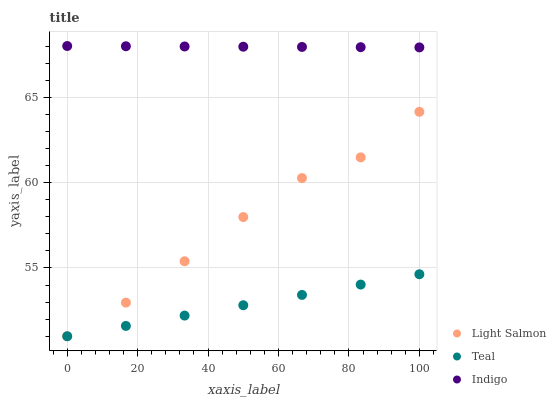Does Teal have the minimum area under the curve?
Answer yes or no. Yes. Does Indigo have the maximum area under the curve?
Answer yes or no. Yes. Does Indigo have the minimum area under the curve?
Answer yes or no. No. Does Teal have the maximum area under the curve?
Answer yes or no. No. Is Teal the smoothest?
Answer yes or no. Yes. Is Light Salmon the roughest?
Answer yes or no. Yes. Is Indigo the smoothest?
Answer yes or no. No. Is Indigo the roughest?
Answer yes or no. No. Does Light Salmon have the lowest value?
Answer yes or no. Yes. Does Indigo have the lowest value?
Answer yes or no. No. Does Indigo have the highest value?
Answer yes or no. Yes. Does Teal have the highest value?
Answer yes or no. No. Is Light Salmon less than Indigo?
Answer yes or no. Yes. Is Indigo greater than Teal?
Answer yes or no. Yes. Does Teal intersect Light Salmon?
Answer yes or no. Yes. Is Teal less than Light Salmon?
Answer yes or no. No. Is Teal greater than Light Salmon?
Answer yes or no. No. Does Light Salmon intersect Indigo?
Answer yes or no. No. 